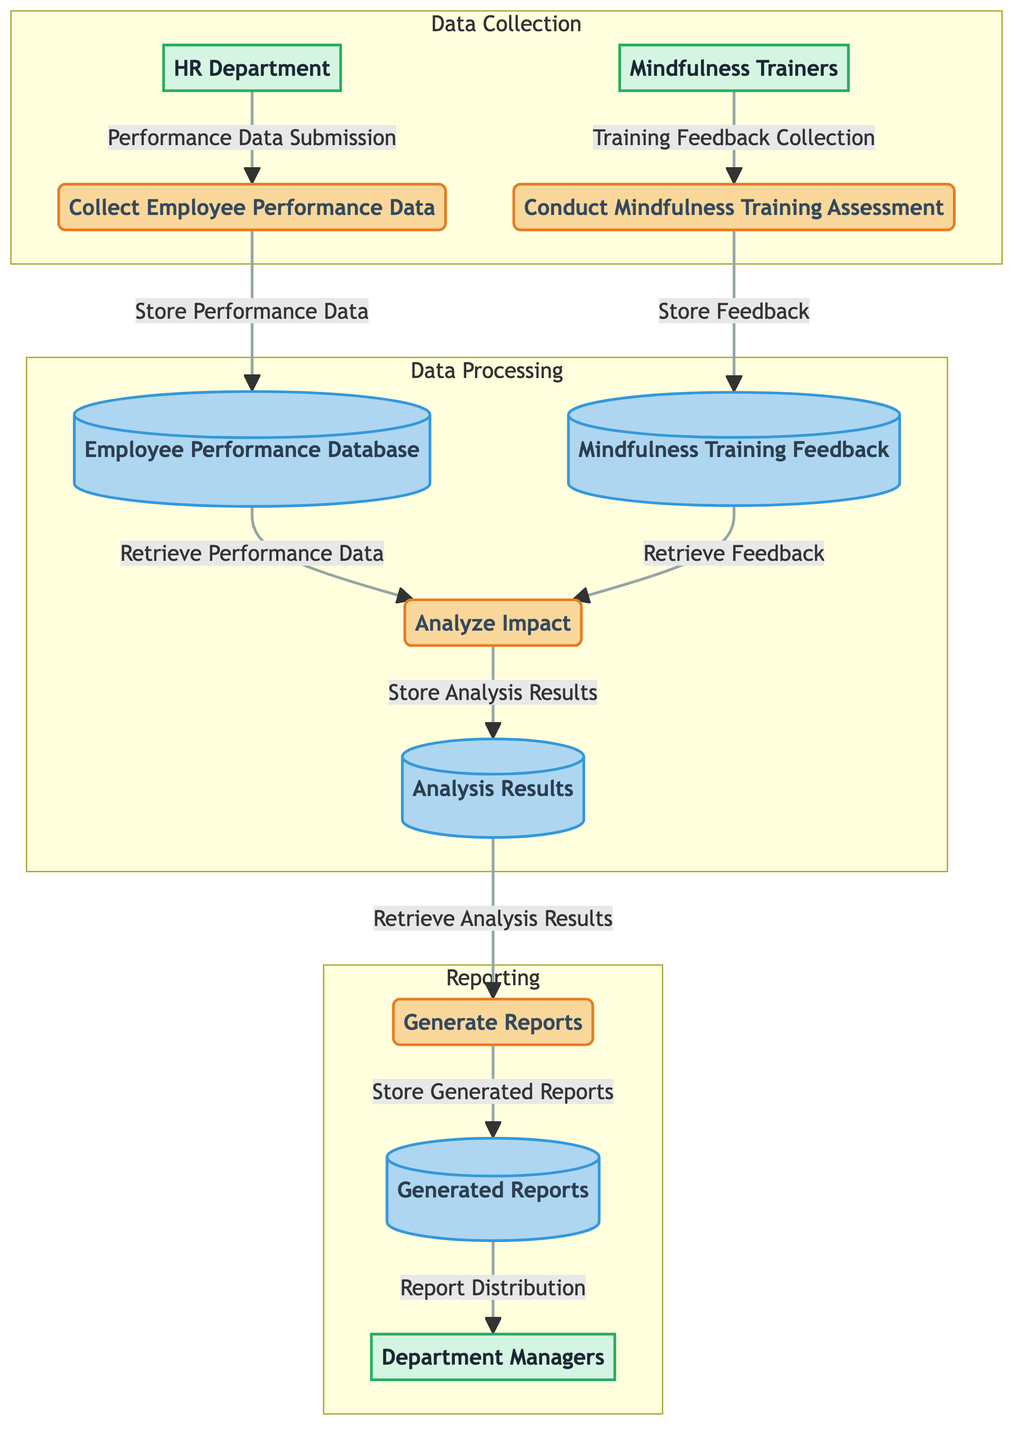What process collects employee performance data? By examining the diagram, the node labeled "Collect Employee Performance Data" indicates the process responsible for gathering performance metrics.
Answer: Collect Employee Performance Data Which data store contains mindfulness training feedback? The diagram shows a data store labeled "Mindfulness Training Feedback," indicating where feedback is stored.
Answer: Mindfulness Training Feedback How many external entities are present in the diagram? Counting the nodes in the "External Entities" section of the diagram, there are three entities: HR Department, Mindfulness Trainers, and Department Managers.
Answer: 3 What type of data flow occurs from the HR Department to the performance data process? The diagram indicates a data flow called "Performance Data Submission," which connects the HR Department to the Collect Employee Performance Data process.
Answer: Performance Data Submission What is stored in the Generated Reports data store? According to the diagram, the data store "Generated Reports" contains comprehensive reports ready for review by management.
Answer: Generated reports What is the purpose of the Analyze Impact process? The diagram describes the Analyze Impact process as evaluating the effect of mindfulness training on employee performance data.
Answer: Evaluating the effect of mindfulness training Which process communicates with the Department Managers? The flow indicates that the Generate Reports process distributes the generated reports to the Department Managers for their review.
Answer: Generate Reports What feedback is collected by the mindfulness trainers? The diagram specifies that mindfulness trainers collect feedback regarding the mindfulness training program, labeled as "Training Feedback Collection."
Answer: Training feedback What is the final output of the data flow? The final output of the data flow, as shown in the diagram, is the reports that are stored in the Generated Reports data store and distributed to Department Managers.
Answer: Reports 